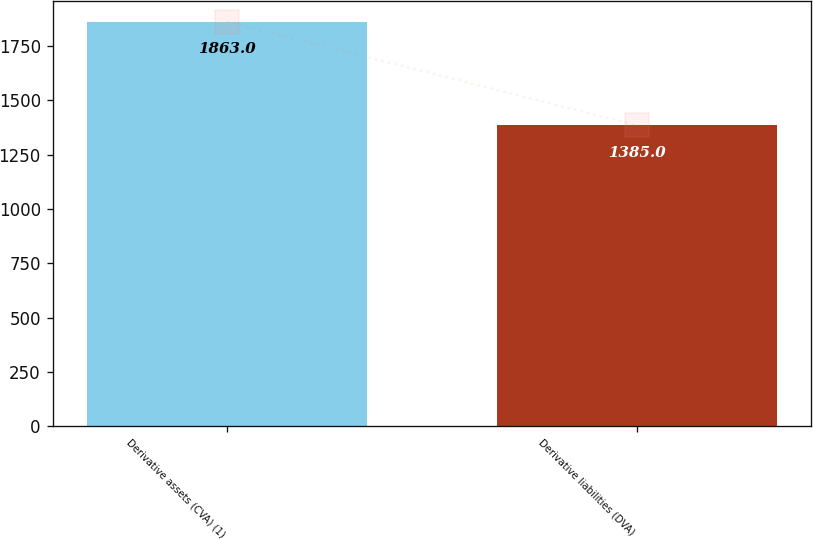<chart> <loc_0><loc_0><loc_500><loc_500><bar_chart><fcel>Derivative assets (CVA) (1)<fcel>Derivative liabilities (DVA)<nl><fcel>1863<fcel>1385<nl></chart> 